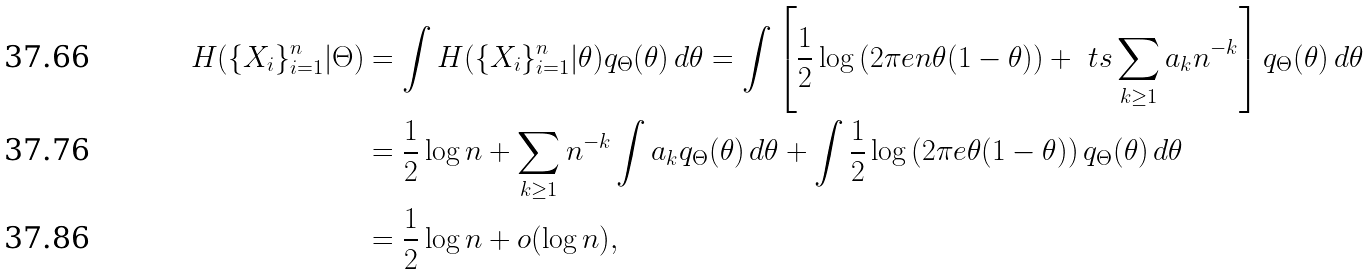Convert formula to latex. <formula><loc_0><loc_0><loc_500><loc_500>H ( \{ X _ { i } \} _ { i = 1 } ^ { n } | \Theta ) & = \int H ( \{ X _ { i } \} _ { i = 1 } ^ { n } | \theta ) q _ { \Theta } ( \theta ) \, d \theta = \int \left [ \frac { 1 } { 2 } \log \left ( 2 \pi e n \theta ( 1 - \theta ) \right ) + { \ t s \sum _ { k \geq 1 } a _ { k } n ^ { - k } } \right ] q _ { \Theta } ( \theta ) \, d \theta \\ & = \frac { 1 } { 2 } \log n + \sum _ { k \geq 1 } n ^ { - k } \int a _ { k } q _ { \Theta } ( \theta ) \, d \theta + \int \frac { 1 } { 2 } \log \left ( 2 \pi e \theta ( 1 - \theta ) \right ) q _ { \Theta } ( \theta ) \, d \theta \\ & = \frac { 1 } { 2 } \log n + o ( \log n ) ,</formula> 